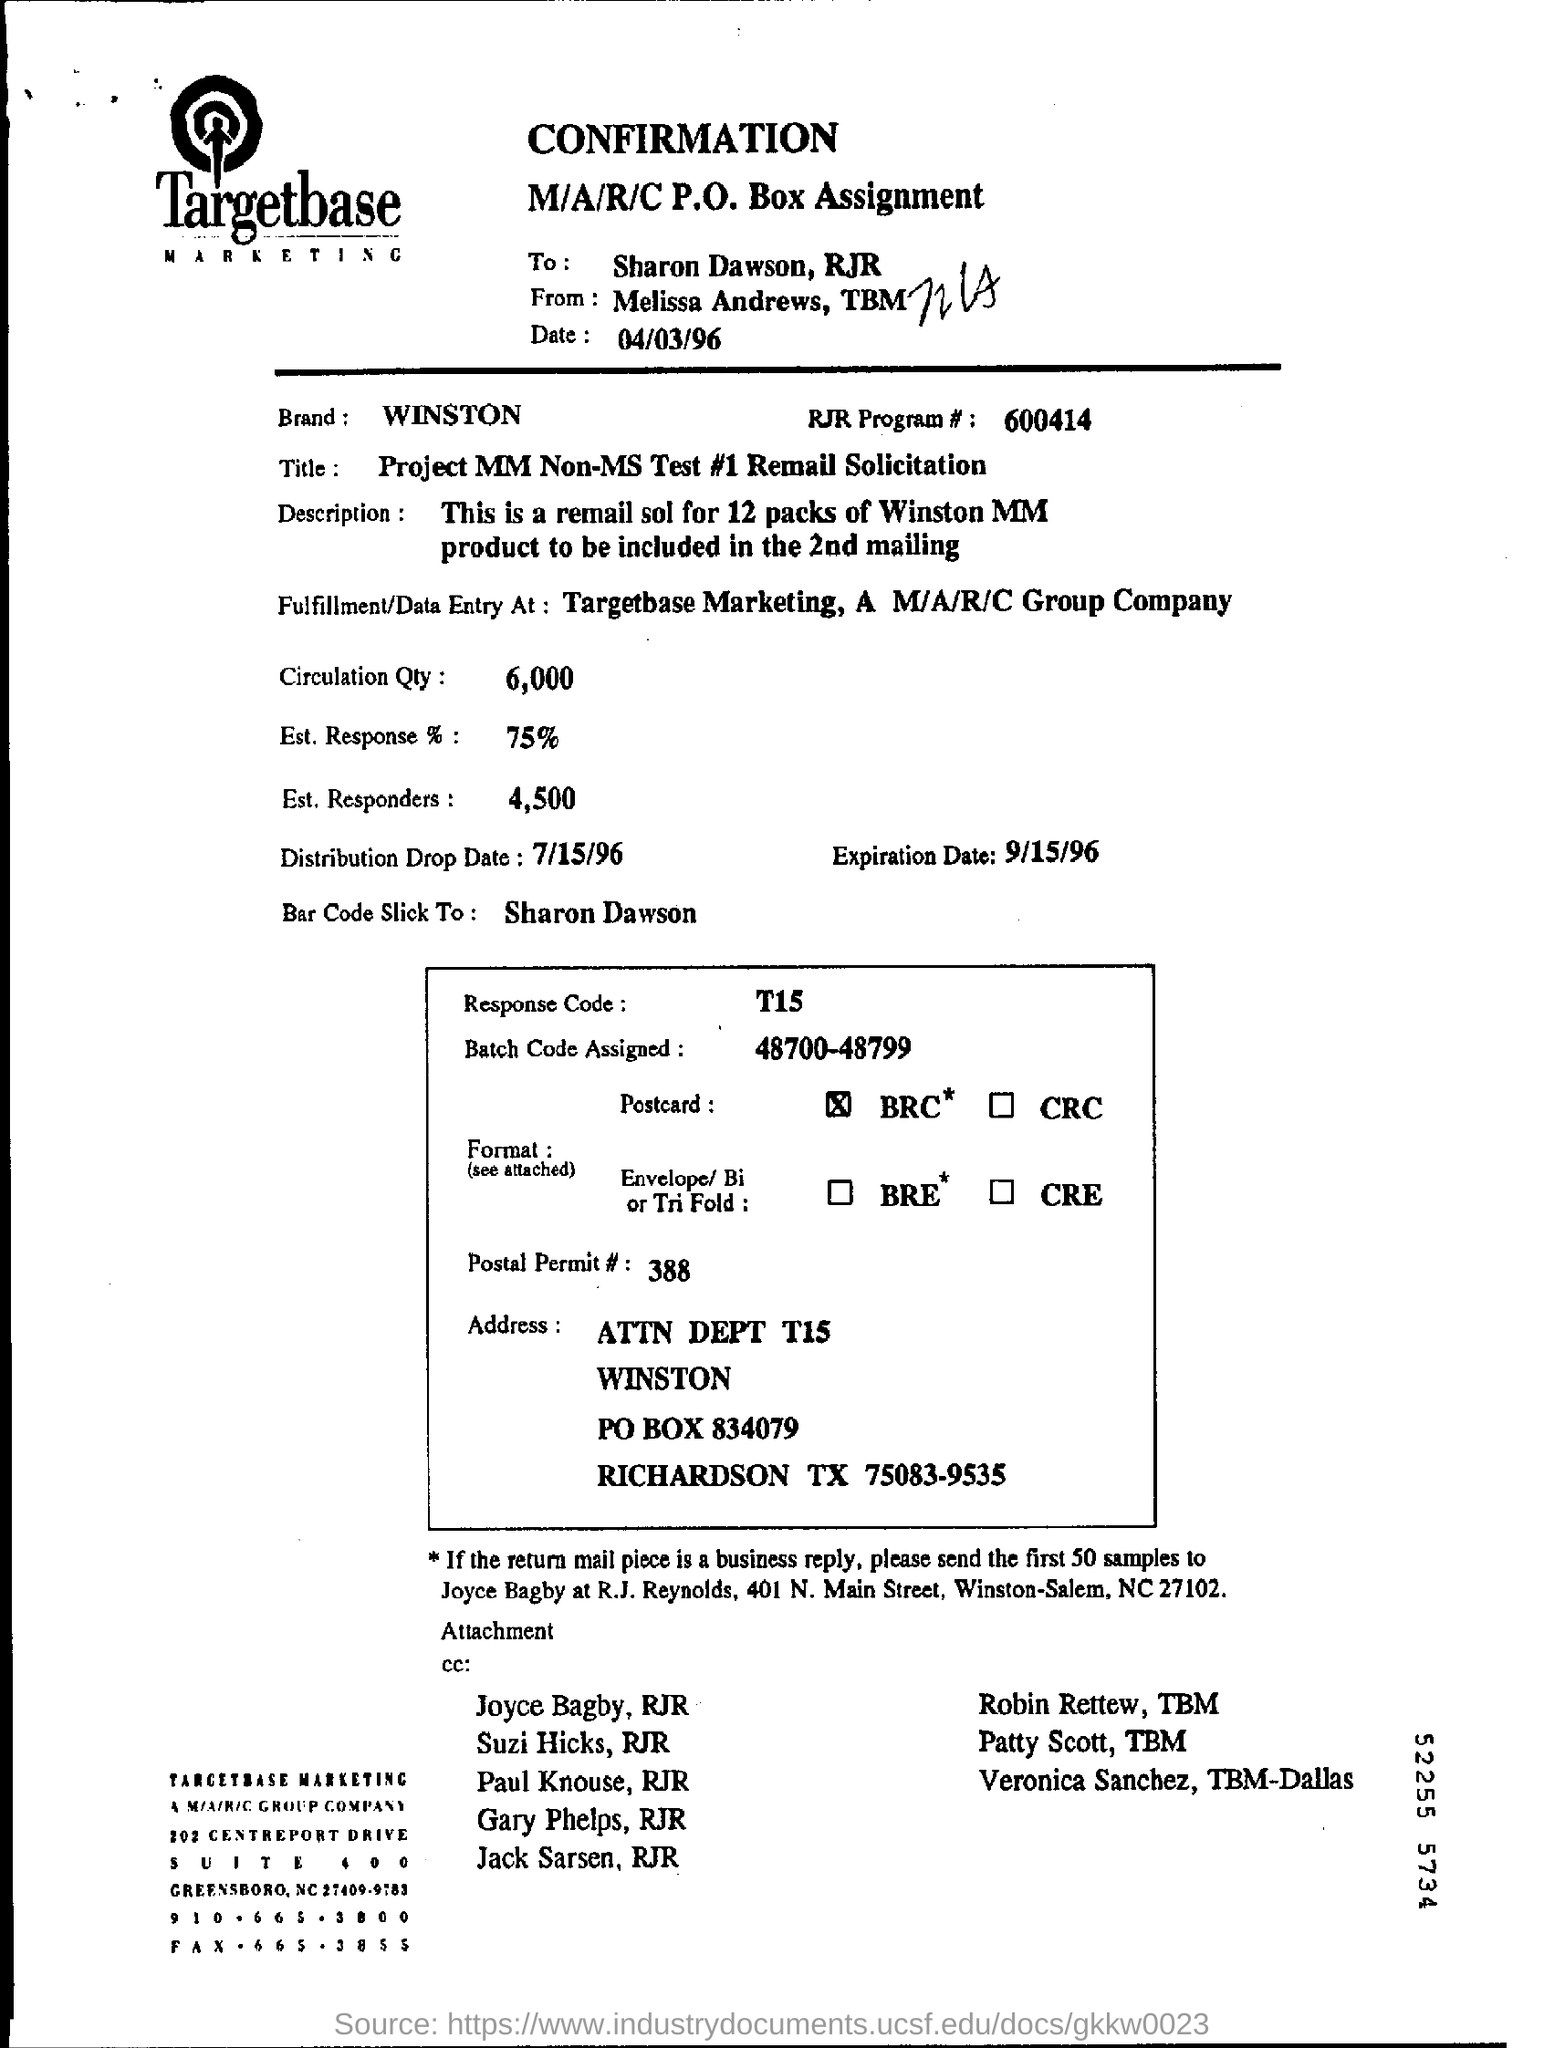Specify some key components in this picture. What is the date mentioned? It is 04/03/96. The quantity or circulation of a specific page is 6000. The brand name mentioned in this document is WINSTON. In the Est response, 75% was noted. The title of the project is "Project MM Non-MS Test #1 Remail Solicitation. 